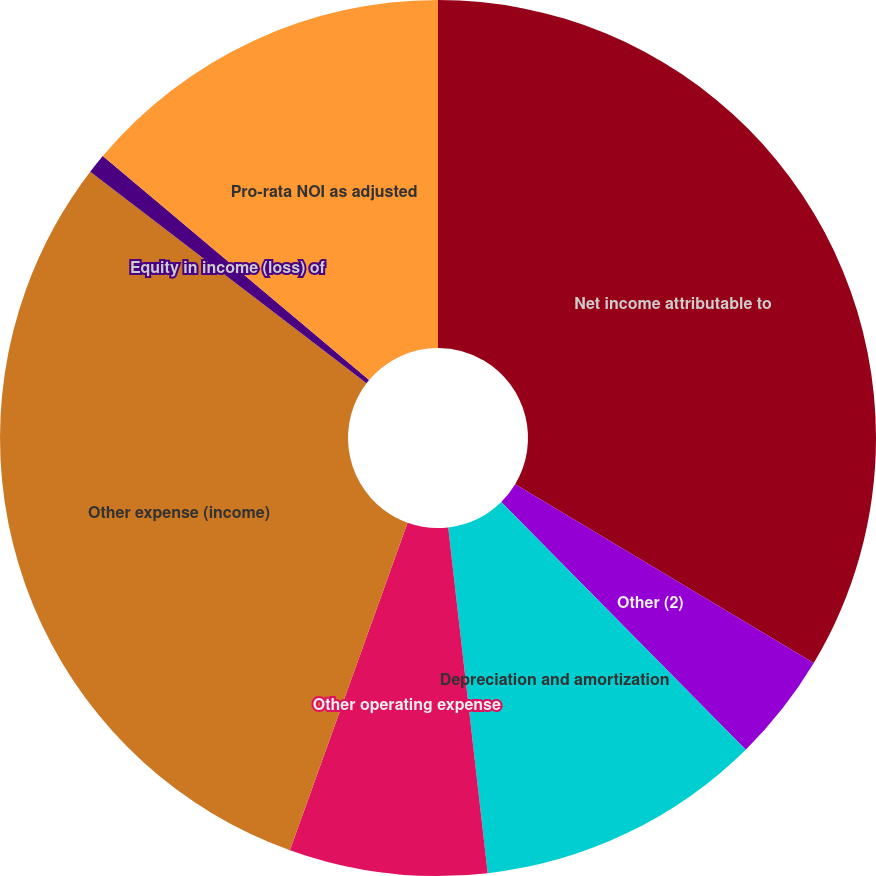Convert chart to OTSL. <chart><loc_0><loc_0><loc_500><loc_500><pie_chart><fcel>Net income attributable to<fcel>Other (2)<fcel>Depreciation and amortization<fcel>Other operating expense<fcel>Other expense (income)<fcel>Equity in income (loss) of<fcel>Pro-rata NOI as adjusted<nl><fcel>33.59%<fcel>4.01%<fcel>10.59%<fcel>7.3%<fcel>29.91%<fcel>0.73%<fcel>13.87%<nl></chart> 